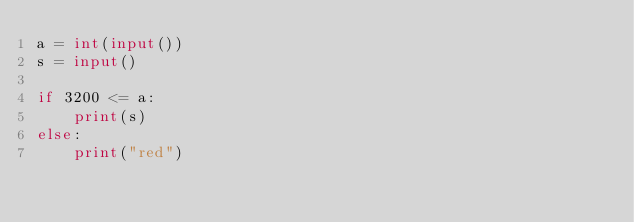<code> <loc_0><loc_0><loc_500><loc_500><_Python_>a = int(input())
s = input()

if 3200 <= a:
    print(s)
else:
    print("red")
</code> 